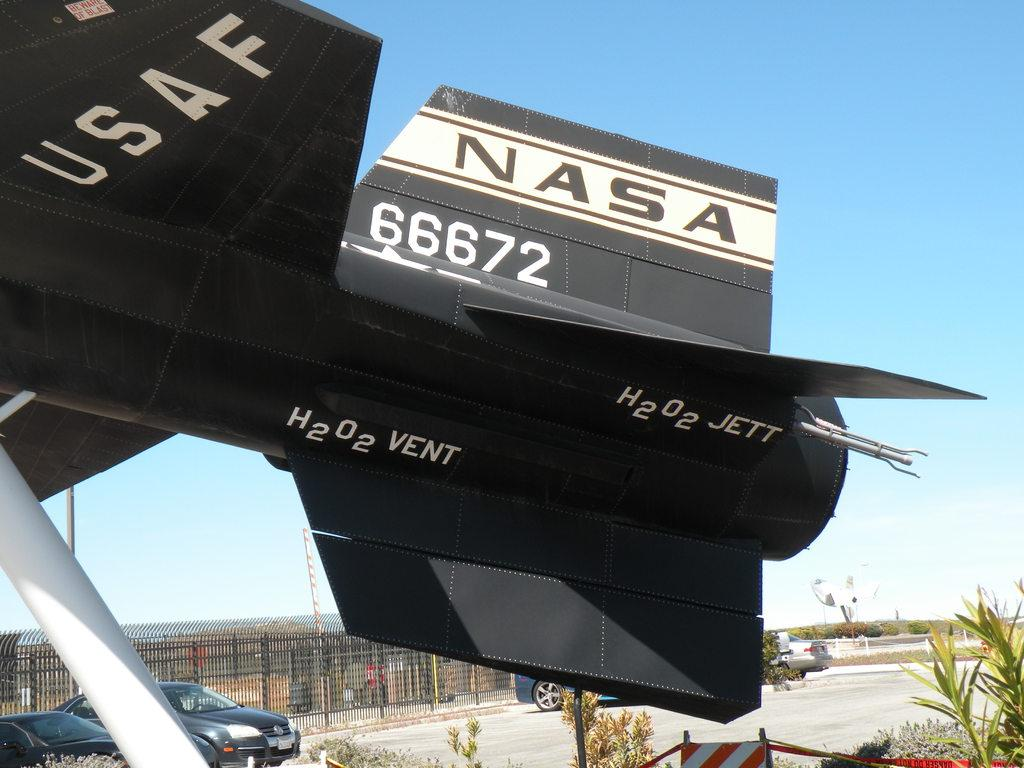<image>
Describe the image concisely. The back end of a jes engine with the NASA logo printed on the tail. 